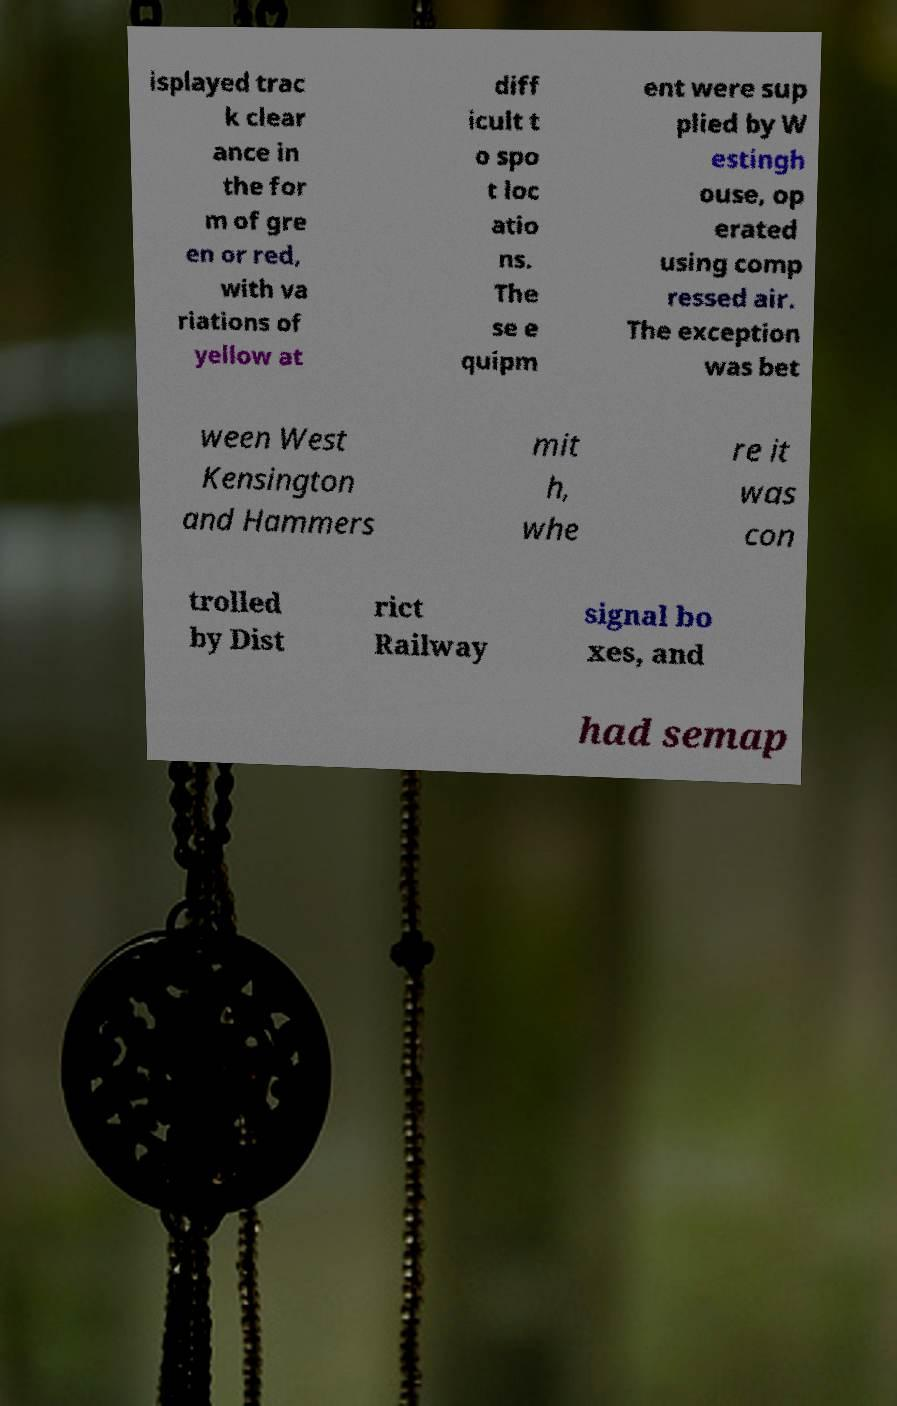Please read and relay the text visible in this image. What does it say? isplayed trac k clear ance in the for m of gre en or red, with va riations of yellow at diff icult t o spo t loc atio ns. The se e quipm ent were sup plied by W estingh ouse, op erated using comp ressed air. The exception was bet ween West Kensington and Hammers mit h, whe re it was con trolled by Dist rict Railway signal bo xes, and had semap 